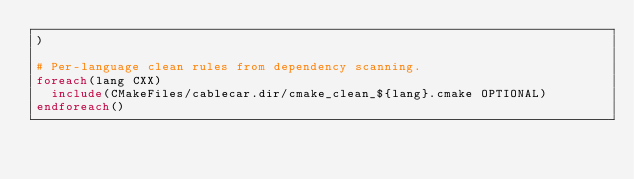<code> <loc_0><loc_0><loc_500><loc_500><_CMake_>)

# Per-language clean rules from dependency scanning.
foreach(lang CXX)
  include(CMakeFiles/cablecar.dir/cmake_clean_${lang}.cmake OPTIONAL)
endforeach()
</code> 